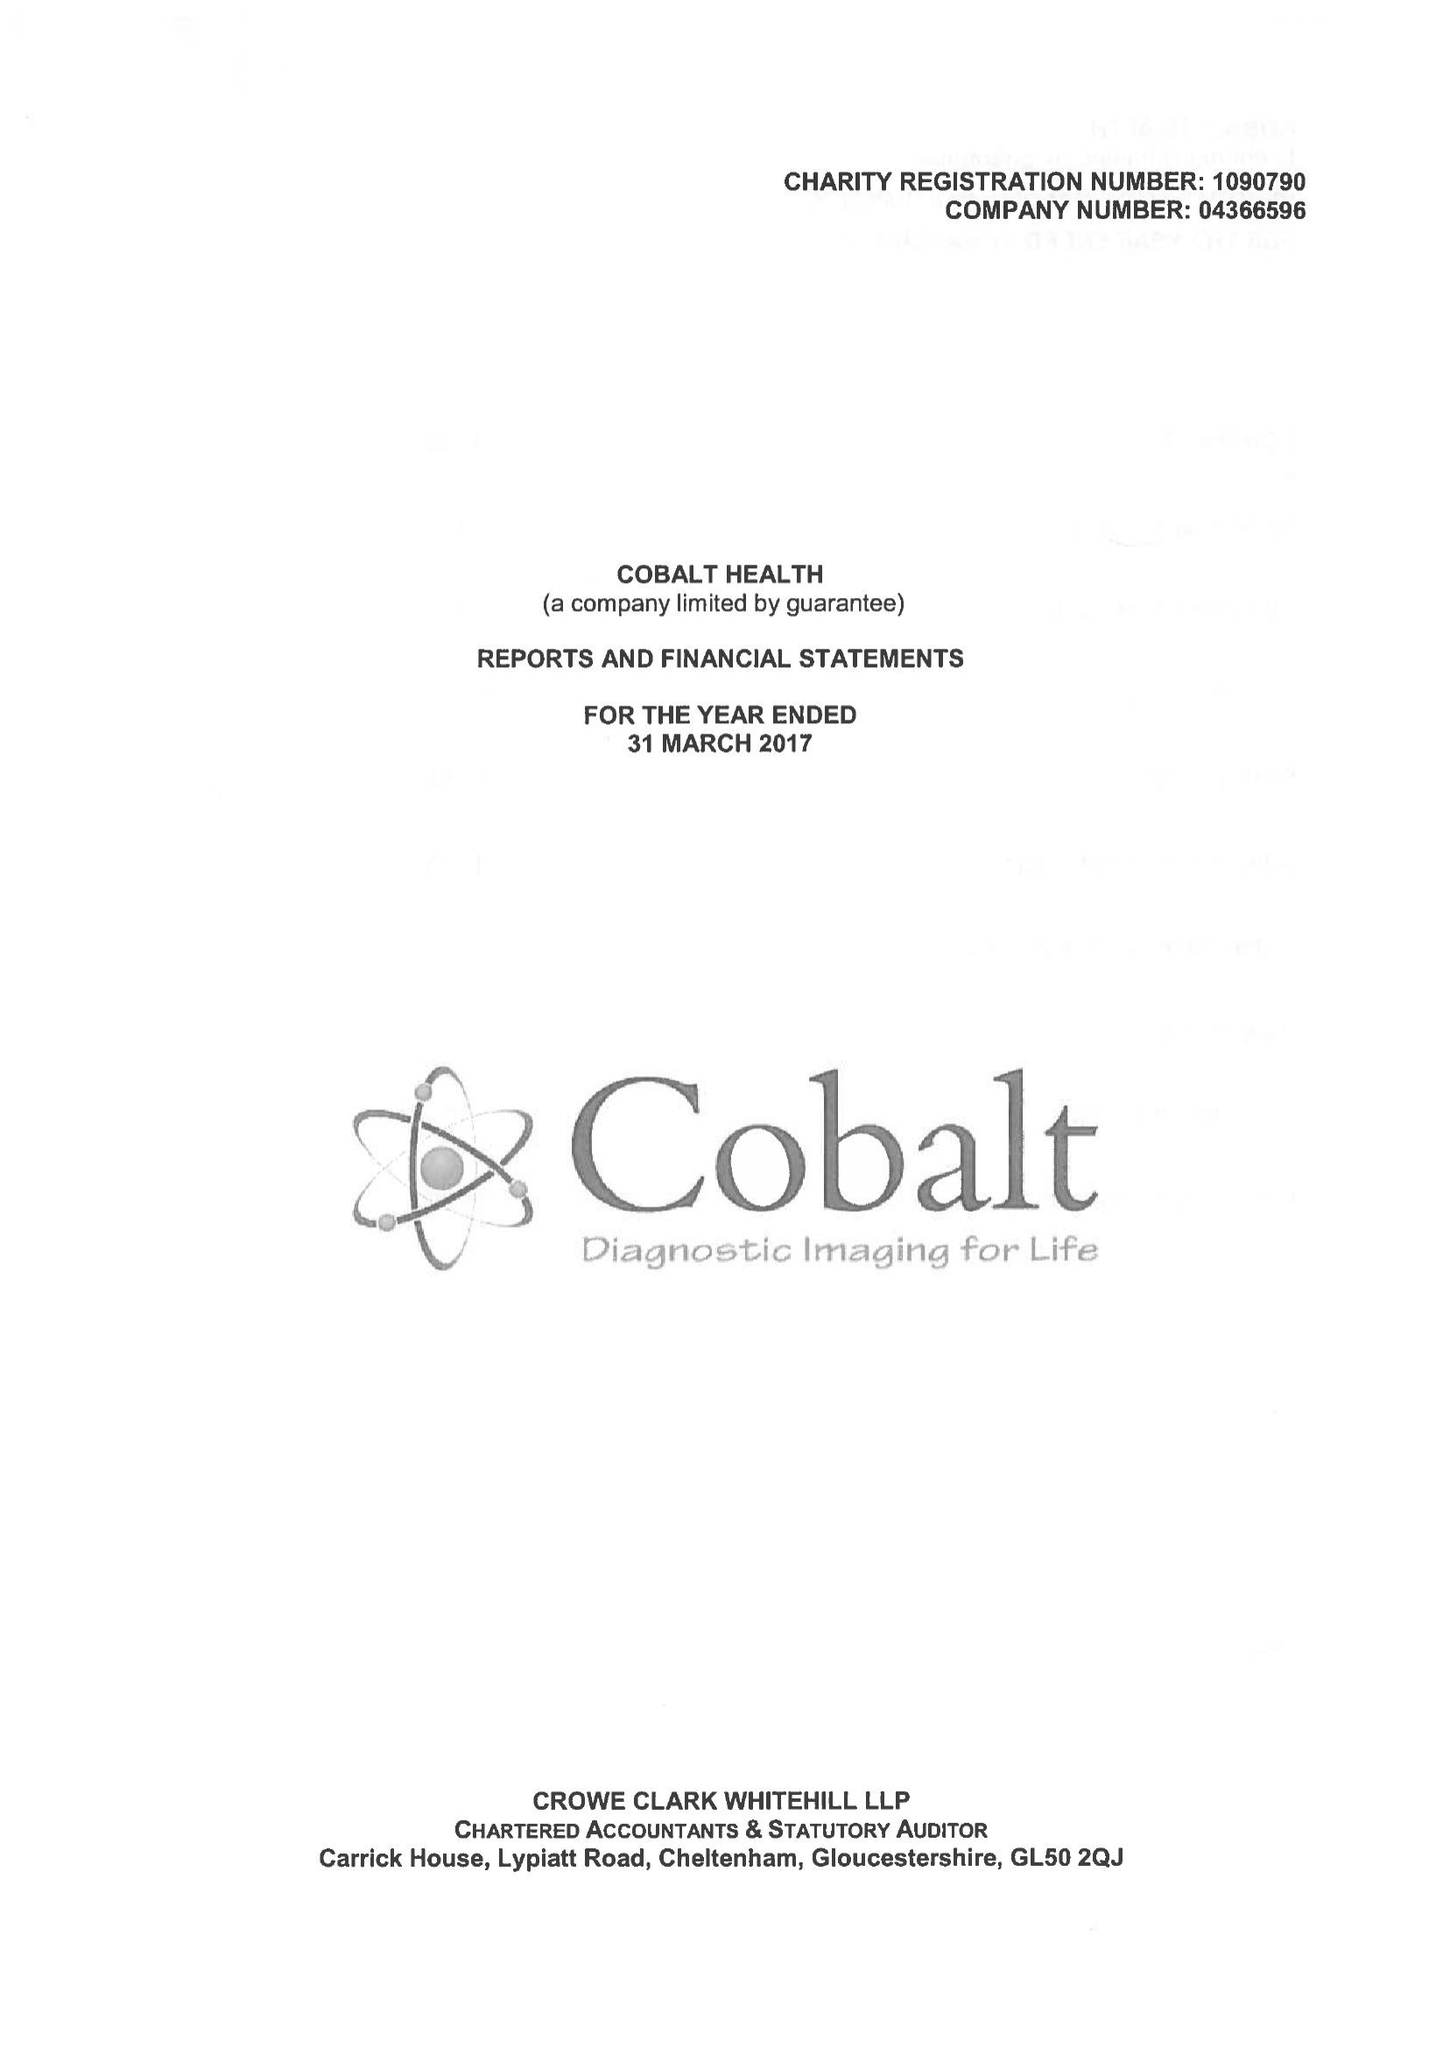What is the value for the address__street_line?
Answer the question using a single word or phrase. THIRLESTAINE ROAD 